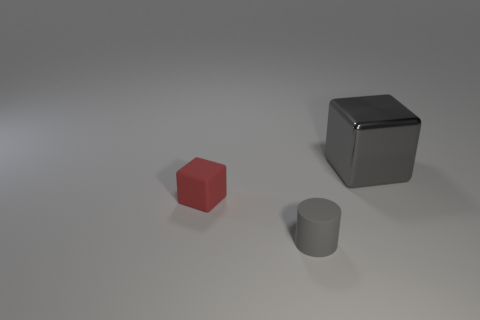Add 3 tiny yellow objects. How many objects exist? 6 Add 2 large metal objects. How many large metal objects exist? 3 Subtract 0 yellow cylinders. How many objects are left? 3 Subtract all blocks. How many objects are left? 1 Subtract all tiny rubber cubes. Subtract all yellow metallic objects. How many objects are left? 2 Add 3 tiny blocks. How many tiny blocks are left? 4 